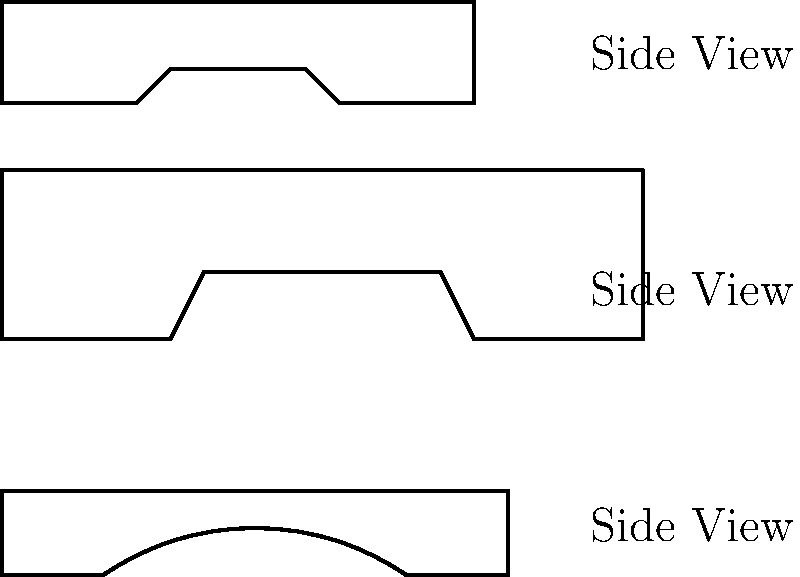Based on the side view silhouettes of three different car types shown above, which one is likely to have the most advanced aerodynamics and potentially the highest top speed? To determine which car is likely to have the most advanced aerodynamics and potentially the highest top speed, we need to analyze the silhouettes:

1. The top silhouette represents a sedan, with a relatively flat roof and traditional shape.
2. The middle silhouette shows an SUV, characterized by its taller body and boxier shape.
3. The bottom silhouette depicts a sports car, with a sleek, low profile and curved lines.

Step-by-step analysis:
1. Aerodynamics: The sports car has the most streamlined shape, with a low front end, curved roof, and tapered rear. This design minimizes air resistance.
2. Frontal area: The sports car has the smallest frontal area, which reduces drag.
3. Ground clearance: The sports car appears to have the lowest ground clearance, which can help reduce turbulence underneath the vehicle.
4. Roof line: The sports car's smooth, curved roof line helps air flow more efficiently over the car.
5. Overall shape: The sports car's silhouette suggests a design focused on performance and speed, unlike the more practical designs of the sedan and SUV.

These factors contribute to better aerodynamics, which directly impacts a car's potential top speed. The sports car's design is optimized to cut through the air with minimal resistance, allowing it to achieve higher speeds more efficiently.
Answer: Sports car (bottom silhouette) 